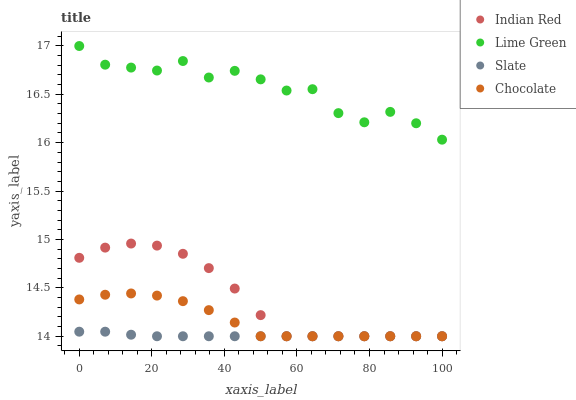Does Slate have the minimum area under the curve?
Answer yes or no. Yes. Does Lime Green have the maximum area under the curve?
Answer yes or no. Yes. Does Indian Red have the minimum area under the curve?
Answer yes or no. No. Does Indian Red have the maximum area under the curve?
Answer yes or no. No. Is Slate the smoothest?
Answer yes or no. Yes. Is Lime Green the roughest?
Answer yes or no. Yes. Is Indian Red the smoothest?
Answer yes or no. No. Is Indian Red the roughest?
Answer yes or no. No. Does Slate have the lowest value?
Answer yes or no. Yes. Does Lime Green have the lowest value?
Answer yes or no. No. Does Lime Green have the highest value?
Answer yes or no. Yes. Does Indian Red have the highest value?
Answer yes or no. No. Is Chocolate less than Lime Green?
Answer yes or no. Yes. Is Lime Green greater than Chocolate?
Answer yes or no. Yes. Does Chocolate intersect Slate?
Answer yes or no. Yes. Is Chocolate less than Slate?
Answer yes or no. No. Is Chocolate greater than Slate?
Answer yes or no. No. Does Chocolate intersect Lime Green?
Answer yes or no. No. 